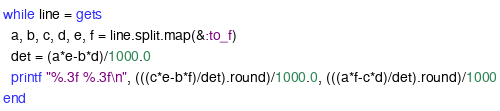<code> <loc_0><loc_0><loc_500><loc_500><_Ruby_>while line = gets
  a, b, c, d, e, f = line.split.map(&:to_f)
  det = (a*e-b*d)/1000.0
  printf "%.3f %.3f\n", (((c*e-b*f)/det).round)/1000.0, (((a*f-c*d)/det).round)/1000
end</code> 